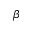Convert formula to latex. <formula><loc_0><loc_0><loc_500><loc_500>\beta</formula> 